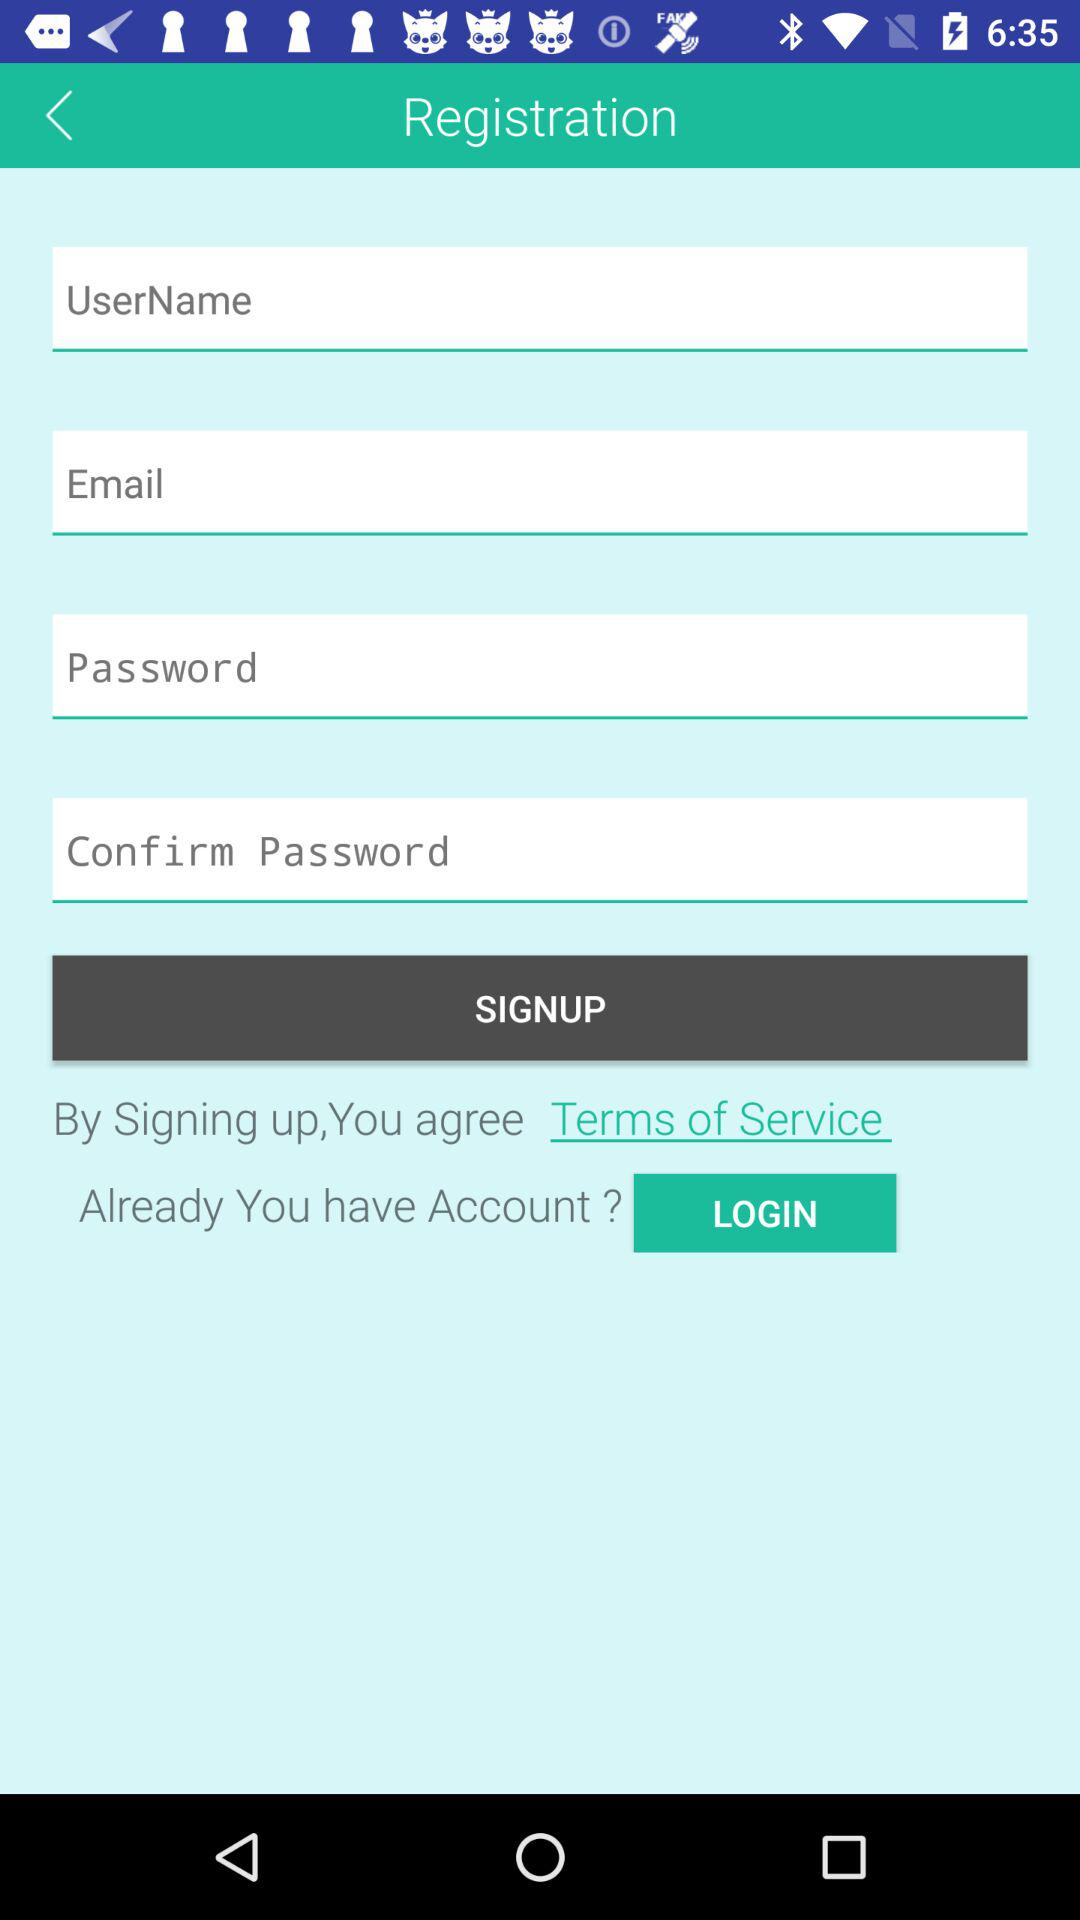How many fields need to be filled out in order to complete registration?
Answer the question using a single word or phrase. 4 